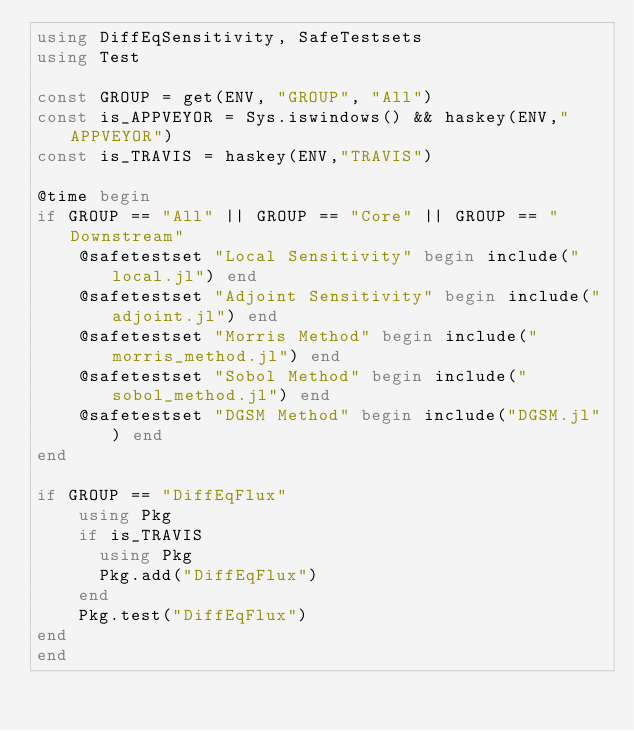Convert code to text. <code><loc_0><loc_0><loc_500><loc_500><_Julia_>using DiffEqSensitivity, SafeTestsets
using Test

const GROUP = get(ENV, "GROUP", "All")
const is_APPVEYOR = Sys.iswindows() && haskey(ENV,"APPVEYOR")
const is_TRAVIS = haskey(ENV,"TRAVIS")

@time begin
if GROUP == "All" || GROUP == "Core" || GROUP == "Downstream"
    @safetestset "Local Sensitivity" begin include("local.jl") end
    @safetestset "Adjoint Sensitivity" begin include("adjoint.jl") end
    @safetestset "Morris Method" begin include("morris_method.jl") end
    @safetestset "Sobol Method" begin include("sobol_method.jl") end
    @safetestset "DGSM Method" begin include("DGSM.jl") end
end

if GROUP == "DiffEqFlux"
    using Pkg
    if is_TRAVIS
      using Pkg
      Pkg.add("DiffEqFlux")
    end
    Pkg.test("DiffEqFlux")
end
end
</code> 